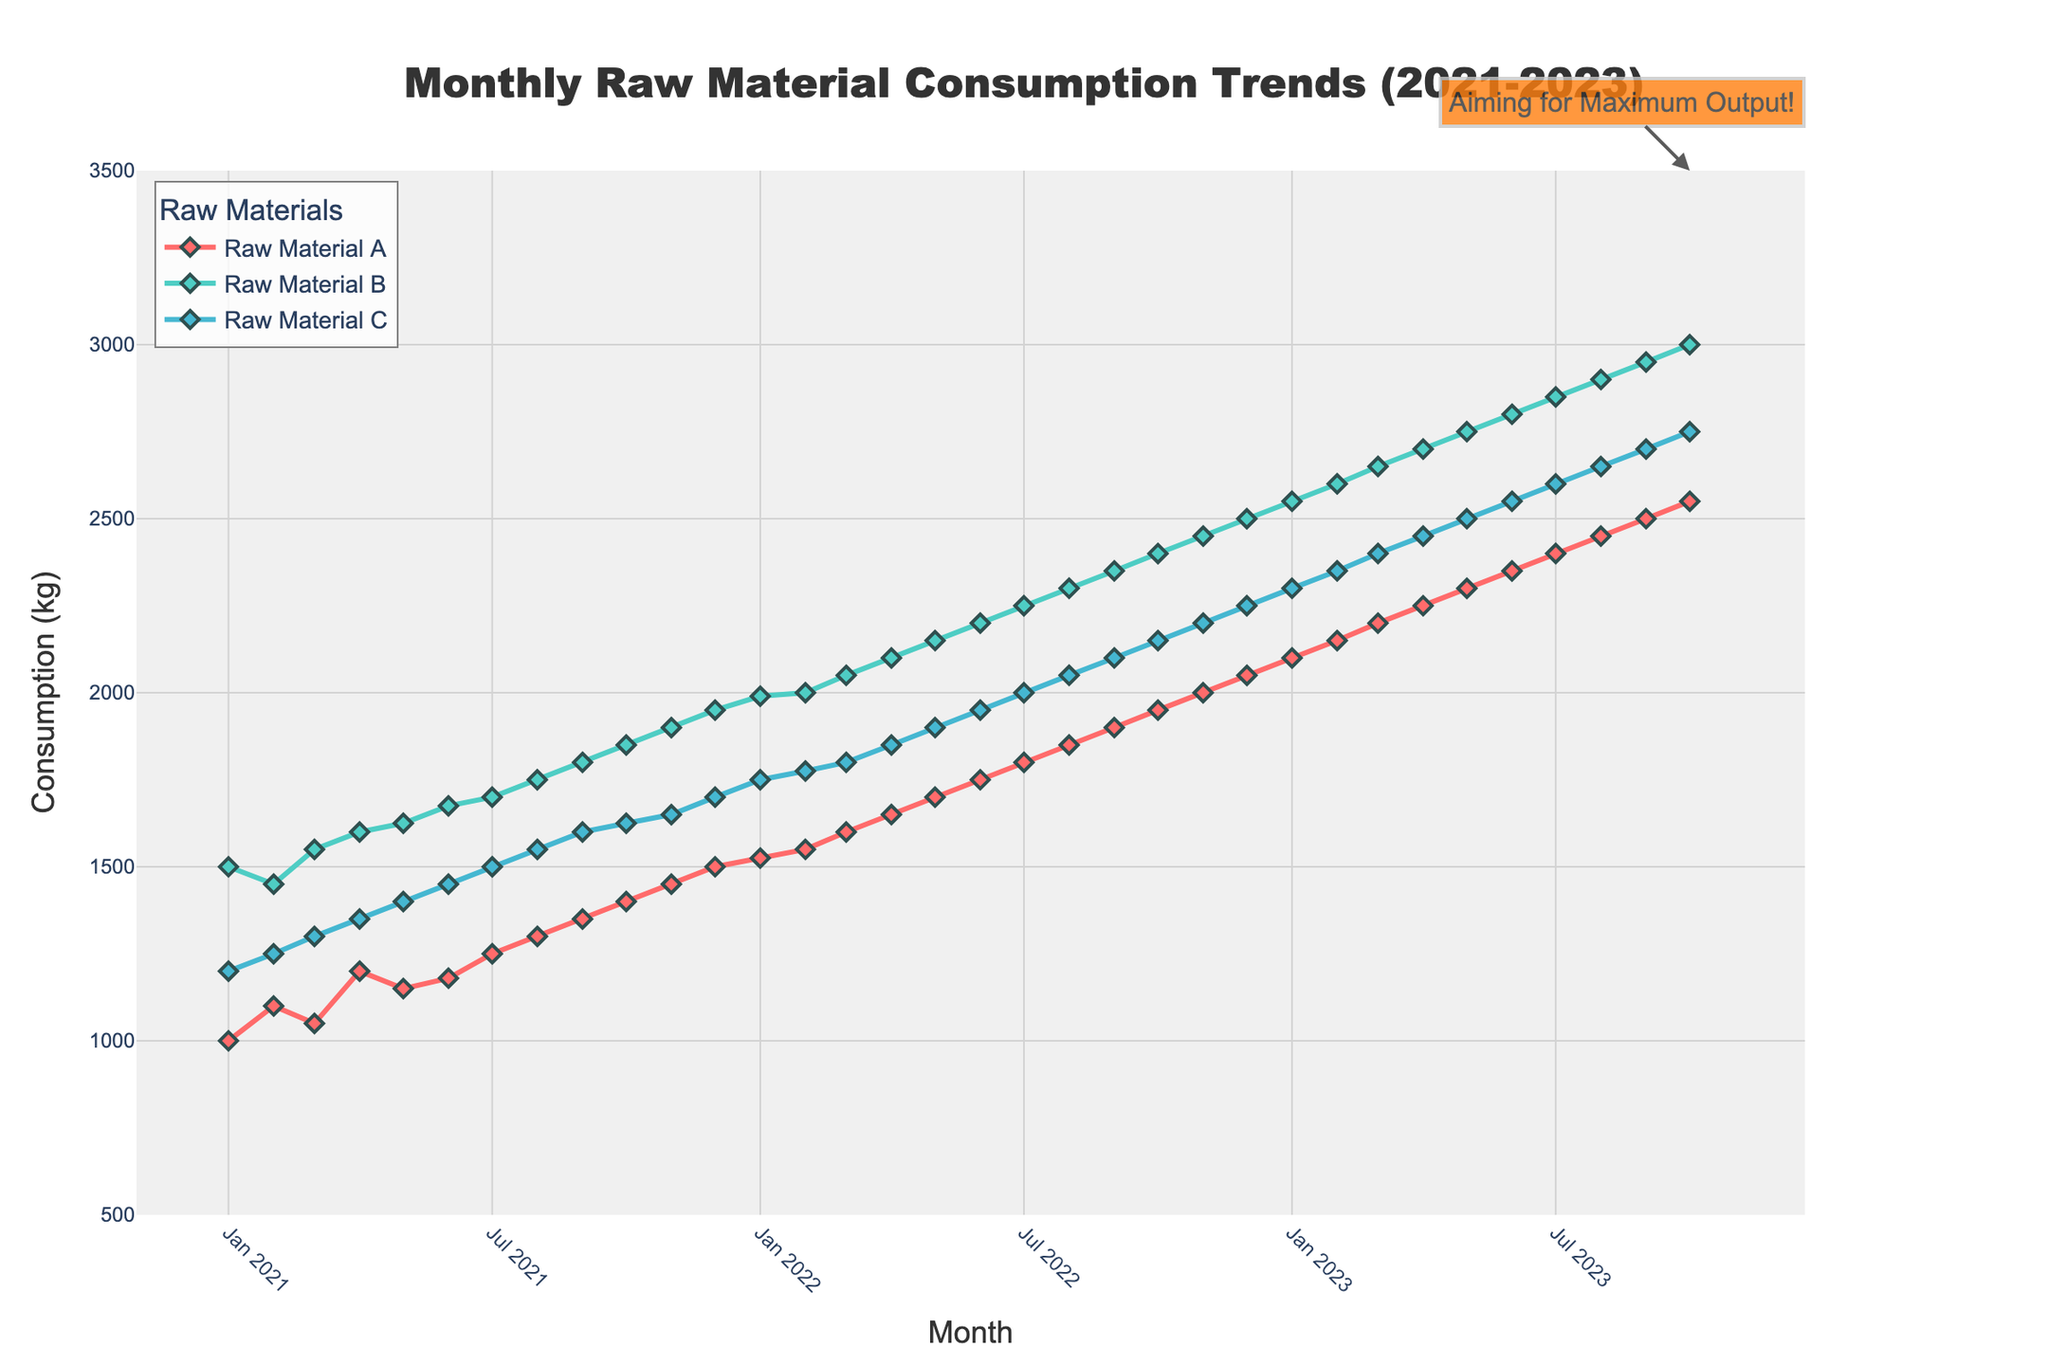How many different raw materials are represented in the plot? The plot shows three different lines for raw materials A, B, and C, each identified by a distinct color and label in the legend.
Answer: Three What is the title of the plot? The title is located at the top center of the plot and reads "Monthly Raw Material Consumption Trends (2021-2023)".
Answer: Monthly Raw Material Consumption Trends (2021-2023) Which raw material had the highest consumption in October 2022? By looking at the October 2022 data points, Raw Material B has the highest consumption of 2400 kg compared to A's 1950 kg and C's 2150 kg.
Answer: Raw Material B What is the trend in raw material consumption for material A over the entire period? The trend for Raw Material A shows a steady increase from 1000 kg in January 2021 to 2550 kg by October 2023, indicating consistent growth.
Answer: Steady increase By how much did Raw Material C's consumption increase from January 2021 to October 2023? The consumption of Raw Material C in January 2021 was 1200 kg and in October 2023 it was 2750 kg. The increase is 2750 - 1200 = 1550 kg.
Answer: 1550 kg Which month saw the highest combined consumption of all raw materials, and what was the amount? By adding up the consumption for each month and comparing, October 2023 saw the highest combined consumption. Raw Material A (2550 kg) + B (3000 kg) + C (2750 kg) totals to 8300 kg.
Answer: October 2023, 8300 kg During which month did Raw Material B's consumption first exceed 2000 kg? In February 2022, Raw Material B's consumption first reached 2000 kg.
Answer: February 2022 Is there a month where the consumption of all three materials was equal? By inspecting the data, there is no single month where Raw Materials A, B, and C had equal consumption levels.
Answer: No What is the general pattern of changes in raw material consumption across the three materials? All three raw materials show a consistent upward trend from January 2021 to October 2023, with varying rates of increase.
Answer: Upward trend What annotation is added to the plot, and what's its significance? The annotation at the top marks "Aiming for Maximum Output!" signifying the goal of achieving peak efficiency and production.
Answer: Aiming for Maximum Output! 